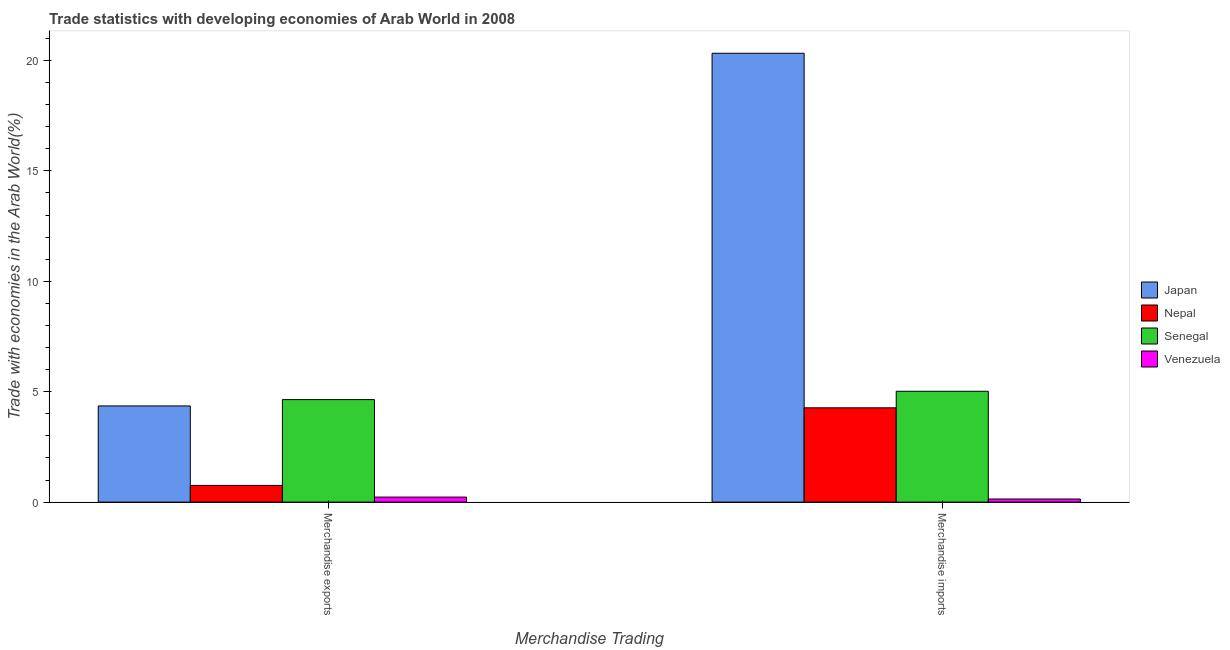How many different coloured bars are there?
Your answer should be compact. 4. How many groups of bars are there?
Offer a terse response. 2. Are the number of bars per tick equal to the number of legend labels?
Keep it short and to the point. Yes. Are the number of bars on each tick of the X-axis equal?
Offer a terse response. Yes. How many bars are there on the 2nd tick from the right?
Offer a very short reply. 4. What is the label of the 2nd group of bars from the left?
Ensure brevity in your answer.  Merchandise imports. What is the merchandise imports in Venezuela?
Provide a short and direct response. 0.14. Across all countries, what is the maximum merchandise imports?
Your answer should be compact. 20.32. Across all countries, what is the minimum merchandise imports?
Make the answer very short. 0.14. In which country was the merchandise exports minimum?
Provide a succinct answer. Venezuela. What is the total merchandise exports in the graph?
Offer a terse response. 9.98. What is the difference between the merchandise exports in Venezuela and that in Nepal?
Your response must be concise. -0.53. What is the difference between the merchandise imports in Nepal and the merchandise exports in Venezuela?
Give a very brief answer. 4.04. What is the average merchandise exports per country?
Provide a short and direct response. 2.5. What is the difference between the merchandise imports and merchandise exports in Nepal?
Your answer should be compact. 3.51. In how many countries, is the merchandise imports greater than 6 %?
Provide a short and direct response. 1. What is the ratio of the merchandise imports in Nepal to that in Japan?
Provide a short and direct response. 0.21. Is the merchandise imports in Senegal less than that in Japan?
Your answer should be compact. Yes. What does the 2nd bar from the left in Merchandise imports represents?
Keep it short and to the point. Nepal. What does the 2nd bar from the right in Merchandise exports represents?
Provide a succinct answer. Senegal. Are all the bars in the graph horizontal?
Offer a very short reply. No. What is the difference between two consecutive major ticks on the Y-axis?
Offer a terse response. 5. Does the graph contain any zero values?
Provide a short and direct response. No. What is the title of the graph?
Provide a succinct answer. Trade statistics with developing economies of Arab World in 2008. What is the label or title of the X-axis?
Your answer should be very brief. Merchandise Trading. What is the label or title of the Y-axis?
Provide a succinct answer. Trade with economies in the Arab World(%). What is the Trade with economies in the Arab World(%) of Japan in Merchandise exports?
Offer a terse response. 4.36. What is the Trade with economies in the Arab World(%) of Nepal in Merchandise exports?
Your answer should be compact. 0.76. What is the Trade with economies in the Arab World(%) of Senegal in Merchandise exports?
Provide a short and direct response. 4.64. What is the Trade with economies in the Arab World(%) of Venezuela in Merchandise exports?
Your response must be concise. 0.23. What is the Trade with economies in the Arab World(%) of Japan in Merchandise imports?
Provide a succinct answer. 20.32. What is the Trade with economies in the Arab World(%) in Nepal in Merchandise imports?
Your answer should be compact. 4.27. What is the Trade with economies in the Arab World(%) of Senegal in Merchandise imports?
Offer a terse response. 5.02. What is the Trade with economies in the Arab World(%) of Venezuela in Merchandise imports?
Keep it short and to the point. 0.14. Across all Merchandise Trading, what is the maximum Trade with economies in the Arab World(%) of Japan?
Keep it short and to the point. 20.32. Across all Merchandise Trading, what is the maximum Trade with economies in the Arab World(%) of Nepal?
Offer a terse response. 4.27. Across all Merchandise Trading, what is the maximum Trade with economies in the Arab World(%) of Senegal?
Your response must be concise. 5.02. Across all Merchandise Trading, what is the maximum Trade with economies in the Arab World(%) in Venezuela?
Give a very brief answer. 0.23. Across all Merchandise Trading, what is the minimum Trade with economies in the Arab World(%) in Japan?
Your answer should be very brief. 4.36. Across all Merchandise Trading, what is the minimum Trade with economies in the Arab World(%) in Nepal?
Keep it short and to the point. 0.76. Across all Merchandise Trading, what is the minimum Trade with economies in the Arab World(%) of Senegal?
Offer a very short reply. 4.64. Across all Merchandise Trading, what is the minimum Trade with economies in the Arab World(%) in Venezuela?
Make the answer very short. 0.14. What is the total Trade with economies in the Arab World(%) in Japan in the graph?
Offer a very short reply. 24.68. What is the total Trade with economies in the Arab World(%) in Nepal in the graph?
Make the answer very short. 5.03. What is the total Trade with economies in the Arab World(%) in Senegal in the graph?
Your answer should be compact. 9.66. What is the total Trade with economies in the Arab World(%) of Venezuela in the graph?
Your answer should be compact. 0.37. What is the difference between the Trade with economies in the Arab World(%) of Japan in Merchandise exports and that in Merchandise imports?
Your response must be concise. -15.97. What is the difference between the Trade with economies in the Arab World(%) of Nepal in Merchandise exports and that in Merchandise imports?
Offer a terse response. -3.51. What is the difference between the Trade with economies in the Arab World(%) in Senegal in Merchandise exports and that in Merchandise imports?
Offer a very short reply. -0.38. What is the difference between the Trade with economies in the Arab World(%) in Venezuela in Merchandise exports and that in Merchandise imports?
Your response must be concise. 0.09. What is the difference between the Trade with economies in the Arab World(%) of Japan in Merchandise exports and the Trade with economies in the Arab World(%) of Nepal in Merchandise imports?
Provide a short and direct response. 0.08. What is the difference between the Trade with economies in the Arab World(%) in Japan in Merchandise exports and the Trade with economies in the Arab World(%) in Senegal in Merchandise imports?
Your answer should be compact. -0.66. What is the difference between the Trade with economies in the Arab World(%) in Japan in Merchandise exports and the Trade with economies in the Arab World(%) in Venezuela in Merchandise imports?
Make the answer very short. 4.21. What is the difference between the Trade with economies in the Arab World(%) of Nepal in Merchandise exports and the Trade with economies in the Arab World(%) of Senegal in Merchandise imports?
Offer a very short reply. -4.26. What is the difference between the Trade with economies in the Arab World(%) of Nepal in Merchandise exports and the Trade with economies in the Arab World(%) of Venezuela in Merchandise imports?
Offer a terse response. 0.62. What is the difference between the Trade with economies in the Arab World(%) of Senegal in Merchandise exports and the Trade with economies in the Arab World(%) of Venezuela in Merchandise imports?
Offer a very short reply. 4.5. What is the average Trade with economies in the Arab World(%) in Japan per Merchandise Trading?
Ensure brevity in your answer.  12.34. What is the average Trade with economies in the Arab World(%) of Nepal per Merchandise Trading?
Ensure brevity in your answer.  2.51. What is the average Trade with economies in the Arab World(%) in Senegal per Merchandise Trading?
Keep it short and to the point. 4.83. What is the average Trade with economies in the Arab World(%) in Venezuela per Merchandise Trading?
Provide a succinct answer. 0.18. What is the difference between the Trade with economies in the Arab World(%) in Japan and Trade with economies in the Arab World(%) in Nepal in Merchandise exports?
Provide a short and direct response. 3.6. What is the difference between the Trade with economies in the Arab World(%) of Japan and Trade with economies in the Arab World(%) of Senegal in Merchandise exports?
Make the answer very short. -0.29. What is the difference between the Trade with economies in the Arab World(%) in Japan and Trade with economies in the Arab World(%) in Venezuela in Merchandise exports?
Your response must be concise. 4.13. What is the difference between the Trade with economies in the Arab World(%) in Nepal and Trade with economies in the Arab World(%) in Senegal in Merchandise exports?
Provide a succinct answer. -3.89. What is the difference between the Trade with economies in the Arab World(%) in Nepal and Trade with economies in the Arab World(%) in Venezuela in Merchandise exports?
Make the answer very short. 0.53. What is the difference between the Trade with economies in the Arab World(%) in Senegal and Trade with economies in the Arab World(%) in Venezuela in Merchandise exports?
Offer a terse response. 4.41. What is the difference between the Trade with economies in the Arab World(%) in Japan and Trade with economies in the Arab World(%) in Nepal in Merchandise imports?
Ensure brevity in your answer.  16.05. What is the difference between the Trade with economies in the Arab World(%) in Japan and Trade with economies in the Arab World(%) in Senegal in Merchandise imports?
Your answer should be compact. 15.3. What is the difference between the Trade with economies in the Arab World(%) in Japan and Trade with economies in the Arab World(%) in Venezuela in Merchandise imports?
Offer a very short reply. 20.18. What is the difference between the Trade with economies in the Arab World(%) in Nepal and Trade with economies in the Arab World(%) in Senegal in Merchandise imports?
Your answer should be compact. -0.75. What is the difference between the Trade with economies in the Arab World(%) in Nepal and Trade with economies in the Arab World(%) in Venezuela in Merchandise imports?
Offer a very short reply. 4.13. What is the difference between the Trade with economies in the Arab World(%) of Senegal and Trade with economies in the Arab World(%) of Venezuela in Merchandise imports?
Provide a succinct answer. 4.88. What is the ratio of the Trade with economies in the Arab World(%) in Japan in Merchandise exports to that in Merchandise imports?
Keep it short and to the point. 0.21. What is the ratio of the Trade with economies in the Arab World(%) of Nepal in Merchandise exports to that in Merchandise imports?
Make the answer very short. 0.18. What is the ratio of the Trade with economies in the Arab World(%) of Senegal in Merchandise exports to that in Merchandise imports?
Provide a succinct answer. 0.92. What is the ratio of the Trade with economies in the Arab World(%) in Venezuela in Merchandise exports to that in Merchandise imports?
Ensure brevity in your answer.  1.61. What is the difference between the highest and the second highest Trade with economies in the Arab World(%) in Japan?
Your answer should be very brief. 15.97. What is the difference between the highest and the second highest Trade with economies in the Arab World(%) of Nepal?
Ensure brevity in your answer.  3.51. What is the difference between the highest and the second highest Trade with economies in the Arab World(%) of Senegal?
Make the answer very short. 0.38. What is the difference between the highest and the second highest Trade with economies in the Arab World(%) in Venezuela?
Ensure brevity in your answer.  0.09. What is the difference between the highest and the lowest Trade with economies in the Arab World(%) in Japan?
Give a very brief answer. 15.97. What is the difference between the highest and the lowest Trade with economies in the Arab World(%) in Nepal?
Your response must be concise. 3.51. What is the difference between the highest and the lowest Trade with economies in the Arab World(%) of Senegal?
Offer a terse response. 0.38. What is the difference between the highest and the lowest Trade with economies in the Arab World(%) of Venezuela?
Keep it short and to the point. 0.09. 